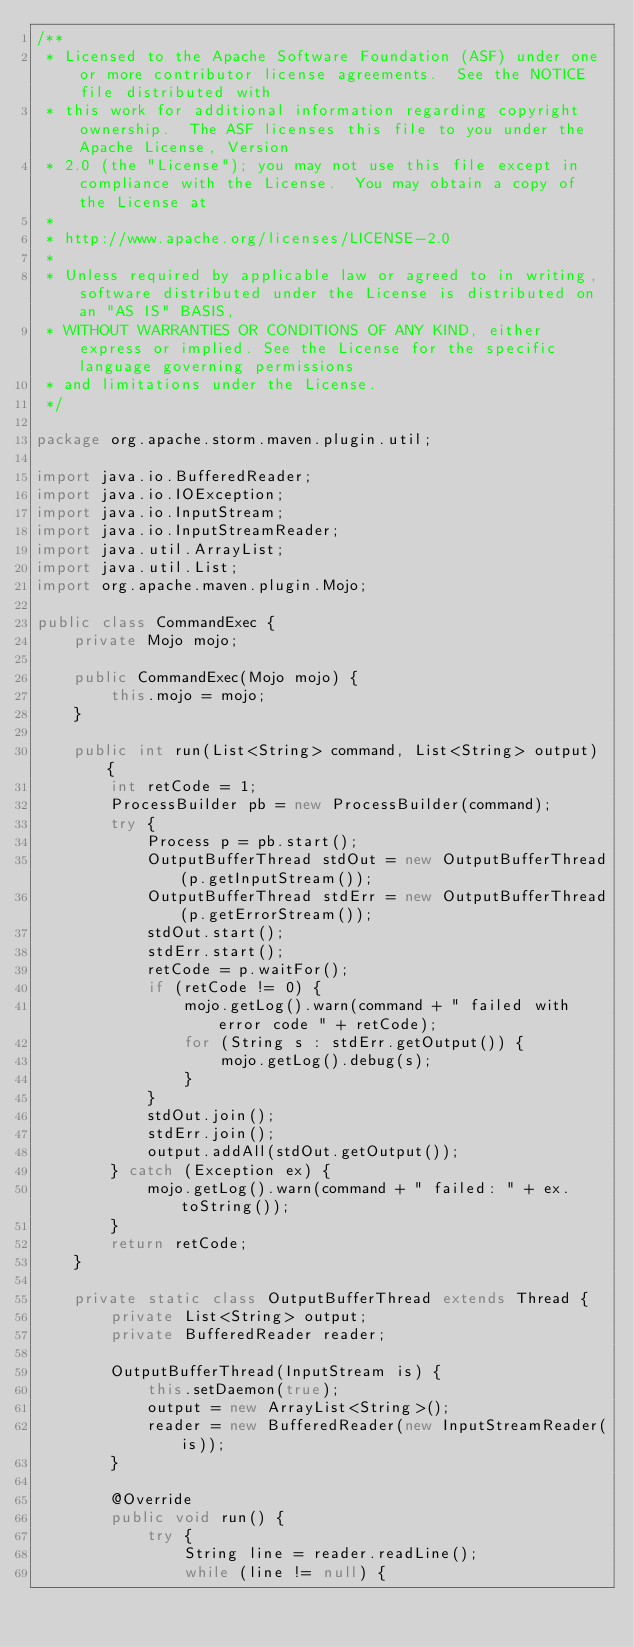Convert code to text. <code><loc_0><loc_0><loc_500><loc_500><_Java_>/**
 * Licensed to the Apache Software Foundation (ASF) under one or more contributor license agreements.  See the NOTICE file distributed with
 * this work for additional information regarding copyright ownership.  The ASF licenses this file to you under the Apache License, Version
 * 2.0 (the "License"); you may not use this file except in compliance with the License.  You may obtain a copy of the License at
 *
 * http://www.apache.org/licenses/LICENSE-2.0
 *
 * Unless required by applicable law or agreed to in writing, software distributed under the License is distributed on an "AS IS" BASIS,
 * WITHOUT WARRANTIES OR CONDITIONS OF ANY KIND, either express or implied. See the License for the specific language governing permissions
 * and limitations under the License.
 */

package org.apache.storm.maven.plugin.util;

import java.io.BufferedReader;
import java.io.IOException;
import java.io.InputStream;
import java.io.InputStreamReader;
import java.util.ArrayList;
import java.util.List;
import org.apache.maven.plugin.Mojo;

public class CommandExec {
    private Mojo mojo;

    public CommandExec(Mojo mojo) {
        this.mojo = mojo;
    }

    public int run(List<String> command, List<String> output) {
        int retCode = 1;
        ProcessBuilder pb = new ProcessBuilder(command);
        try {
            Process p = pb.start();
            OutputBufferThread stdOut = new OutputBufferThread(p.getInputStream());
            OutputBufferThread stdErr = new OutputBufferThread(p.getErrorStream());
            stdOut.start();
            stdErr.start();
            retCode = p.waitFor();
            if (retCode != 0) {
                mojo.getLog().warn(command + " failed with error code " + retCode);
                for (String s : stdErr.getOutput()) {
                    mojo.getLog().debug(s);
                }
            }
            stdOut.join();
            stdErr.join();
            output.addAll(stdOut.getOutput());
        } catch (Exception ex) {
            mojo.getLog().warn(command + " failed: " + ex.toString());
        }
        return retCode;
    }

    private static class OutputBufferThread extends Thread {
        private List<String> output;
        private BufferedReader reader;

        OutputBufferThread(InputStream is) {
            this.setDaemon(true);
            output = new ArrayList<String>();
            reader = new BufferedReader(new InputStreamReader(is));
        }

        @Override
        public void run() {
            try {
                String line = reader.readLine();
                while (line != null) {</code> 